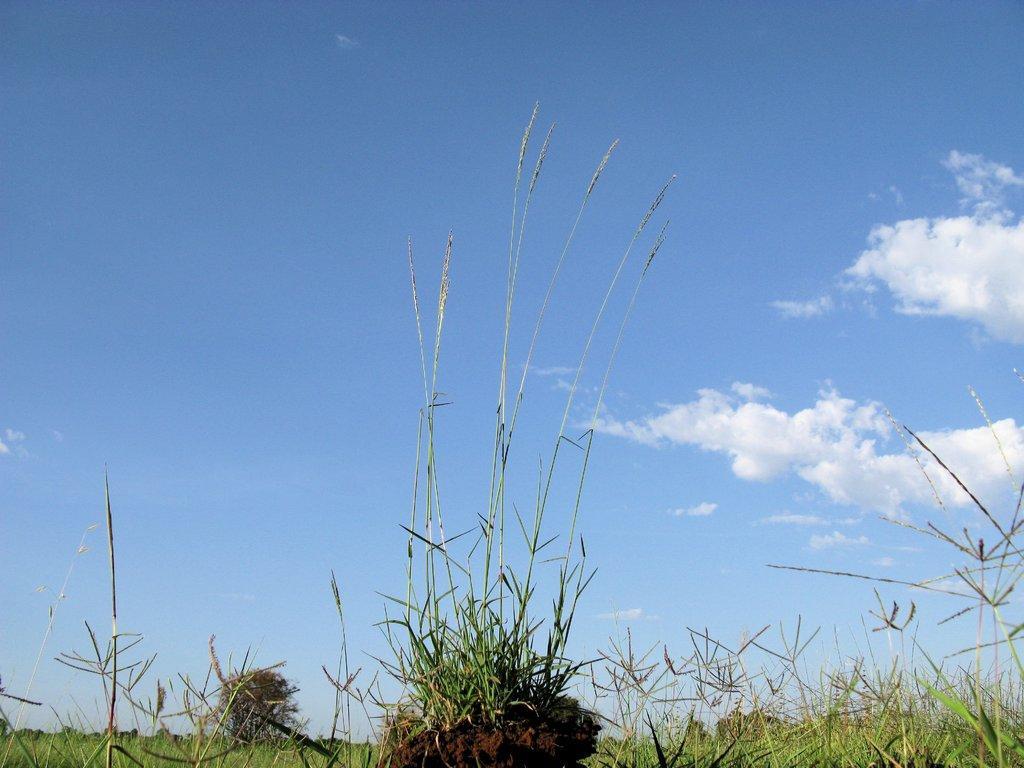Please provide a concise description of this image. As we can see in the image there is grass, plant, sky and clouds. 